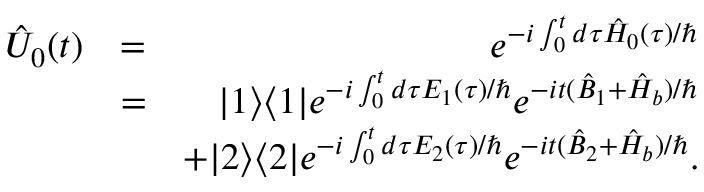<formula> <loc_0><loc_0><loc_500><loc_500>\begin{array} { r l r } { \hat { U } _ { 0 } ( t ) } & { = } & { e ^ { - i \int _ { 0 } ^ { t } d \tau \hat { H } _ { 0 } ( \tau ) / } } \\ & { = } & { | 1 \rangle \langle 1 | e ^ { - i \int _ { 0 } ^ { t } d \tau E _ { 1 } ( \tau ) / } e ^ { - i t ( \hat { B } _ { 1 } + \hat { H } _ { b } ) / } } \\ & { + | 2 \rangle \langle 2 | e ^ { - i \int _ { 0 } ^ { t } d \tau E _ { 2 } ( \tau ) / } e ^ { - i t ( \hat { B } _ { 2 } + \hat { H } _ { b } ) / } . } \end{array}</formula> 